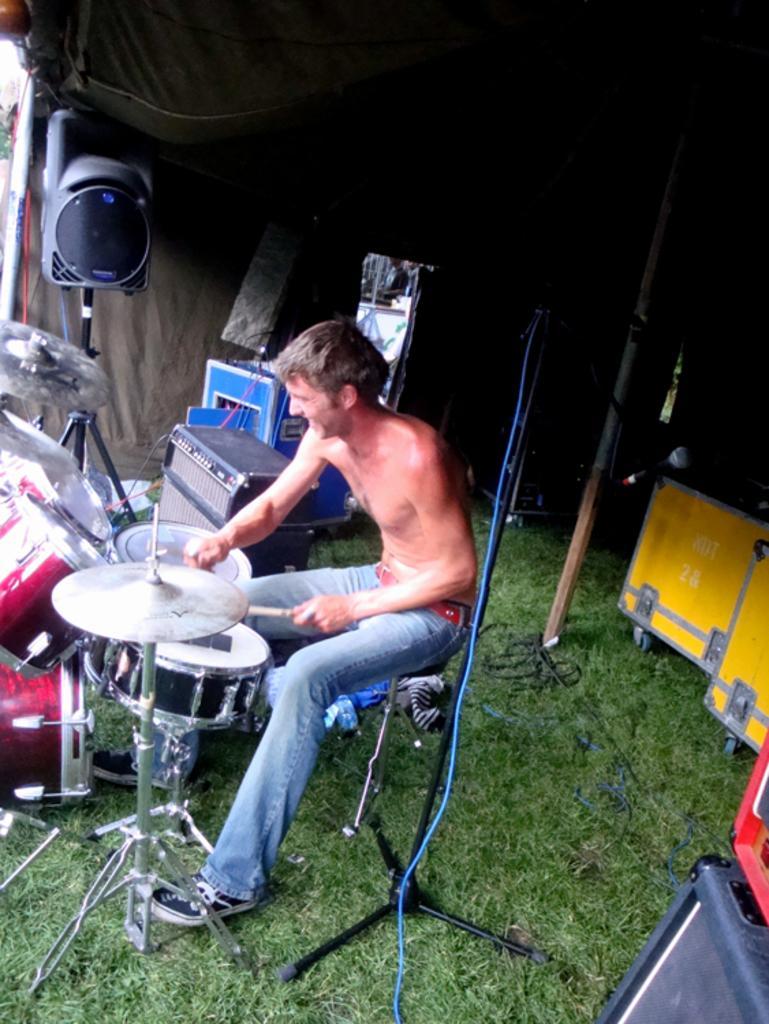Please provide a concise description of this image. In the center of the image there is a man sitting and playing a band behind him there is a stand. There is a speaker. At the top there is a tent. At the bottom there is grass. 